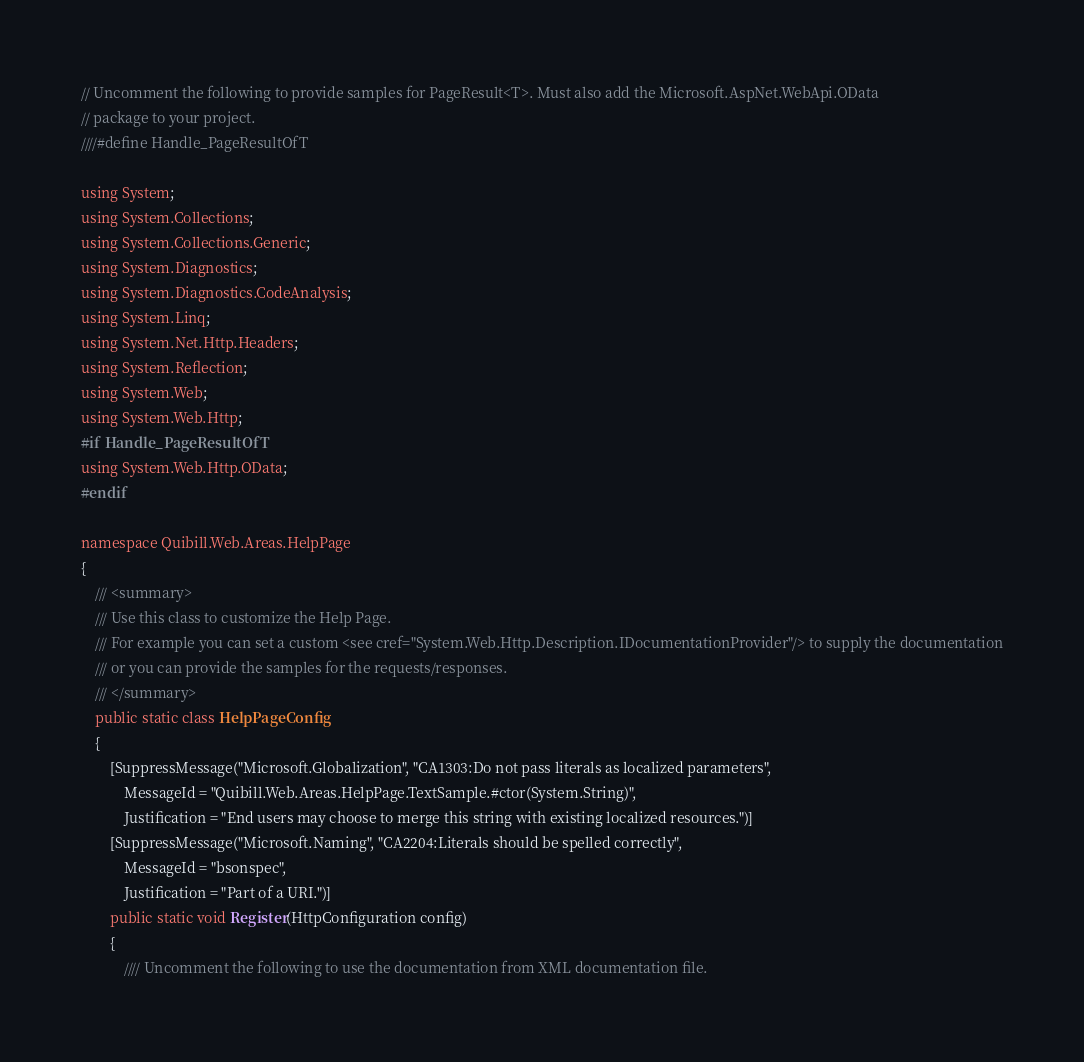Convert code to text. <code><loc_0><loc_0><loc_500><loc_500><_C#_>// Uncomment the following to provide samples for PageResult<T>. Must also add the Microsoft.AspNet.WebApi.OData
// package to your project.
////#define Handle_PageResultOfT

using System;
using System.Collections;
using System.Collections.Generic;
using System.Diagnostics;
using System.Diagnostics.CodeAnalysis;
using System.Linq;
using System.Net.Http.Headers;
using System.Reflection;
using System.Web;
using System.Web.Http;
#if Handle_PageResultOfT
using System.Web.Http.OData;
#endif

namespace Quibill.Web.Areas.HelpPage
{
    /// <summary>
    /// Use this class to customize the Help Page.
    /// For example you can set a custom <see cref="System.Web.Http.Description.IDocumentationProvider"/> to supply the documentation
    /// or you can provide the samples for the requests/responses.
    /// </summary>
    public static class HelpPageConfig
    {
        [SuppressMessage("Microsoft.Globalization", "CA1303:Do not pass literals as localized parameters",
            MessageId = "Quibill.Web.Areas.HelpPage.TextSample.#ctor(System.String)",
            Justification = "End users may choose to merge this string with existing localized resources.")]
        [SuppressMessage("Microsoft.Naming", "CA2204:Literals should be spelled correctly",
            MessageId = "bsonspec",
            Justification = "Part of a URI.")]
        public static void Register(HttpConfiguration config)
        {
            //// Uncomment the following to use the documentation from XML documentation file.</code> 